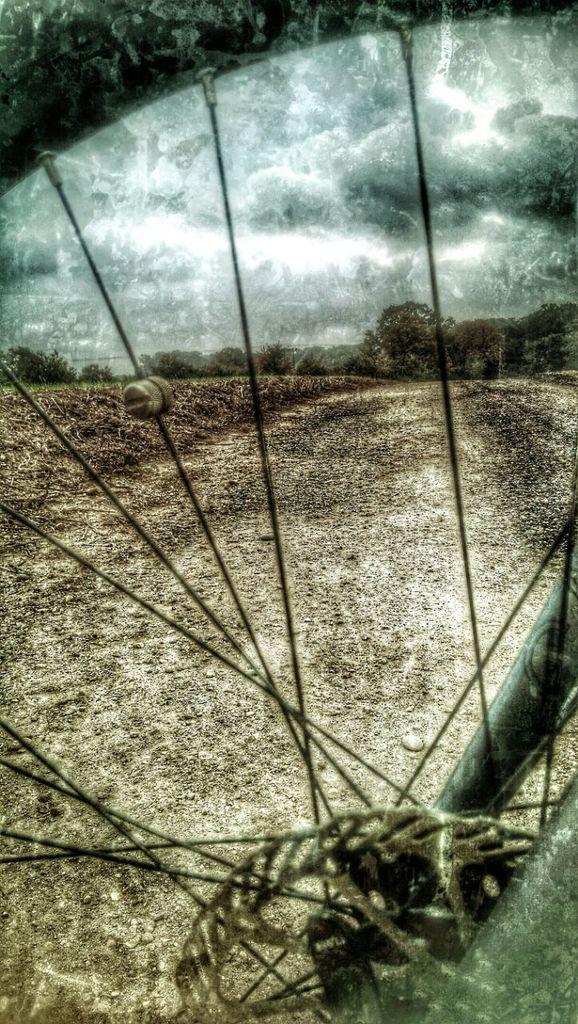Describe this image in one or two sentences. In this picture we can see the sky, ground and trees. In this picture we can see wheel of a bicycle. We can see nipples, spokes, chain and rods. 